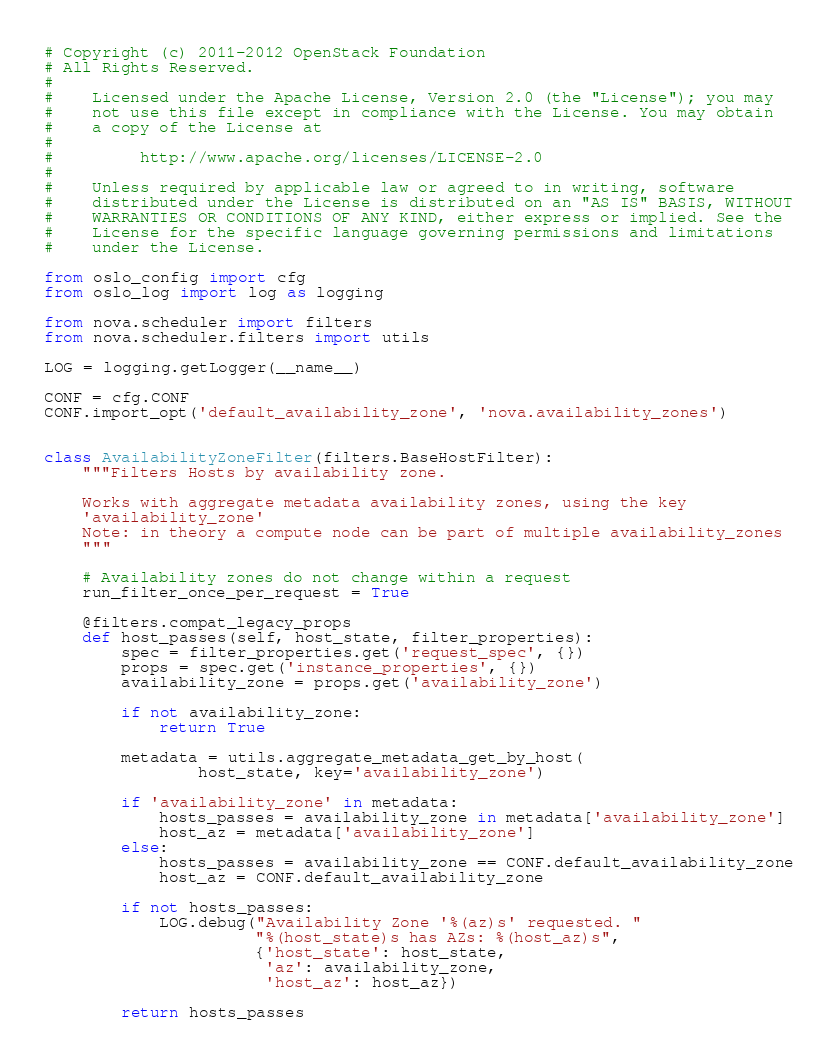Convert code to text. <code><loc_0><loc_0><loc_500><loc_500><_Python_># Copyright (c) 2011-2012 OpenStack Foundation
# All Rights Reserved.
#
#    Licensed under the Apache License, Version 2.0 (the "License"); you may
#    not use this file except in compliance with the License. You may obtain
#    a copy of the License at
#
#         http://www.apache.org/licenses/LICENSE-2.0
#
#    Unless required by applicable law or agreed to in writing, software
#    distributed under the License is distributed on an "AS IS" BASIS, WITHOUT
#    WARRANTIES OR CONDITIONS OF ANY KIND, either express or implied. See the
#    License for the specific language governing permissions and limitations
#    under the License.

from oslo_config import cfg
from oslo_log import log as logging

from nova.scheduler import filters
from nova.scheduler.filters import utils

LOG = logging.getLogger(__name__)

CONF = cfg.CONF
CONF.import_opt('default_availability_zone', 'nova.availability_zones')


class AvailabilityZoneFilter(filters.BaseHostFilter):
    """Filters Hosts by availability zone.

    Works with aggregate metadata availability zones, using the key
    'availability_zone'
    Note: in theory a compute node can be part of multiple availability_zones
    """

    # Availability zones do not change within a request
    run_filter_once_per_request = True

    @filters.compat_legacy_props
    def host_passes(self, host_state, filter_properties):
        spec = filter_properties.get('request_spec', {})
        props = spec.get('instance_properties', {})
        availability_zone = props.get('availability_zone')

        if not availability_zone:
            return True

        metadata = utils.aggregate_metadata_get_by_host(
                host_state, key='availability_zone')

        if 'availability_zone' in metadata:
            hosts_passes = availability_zone in metadata['availability_zone']
            host_az = metadata['availability_zone']
        else:
            hosts_passes = availability_zone == CONF.default_availability_zone
            host_az = CONF.default_availability_zone

        if not hosts_passes:
            LOG.debug("Availability Zone '%(az)s' requested. "
                      "%(host_state)s has AZs: %(host_az)s",
                      {'host_state': host_state,
                       'az': availability_zone,
                       'host_az': host_az})

        return hosts_passes
</code> 